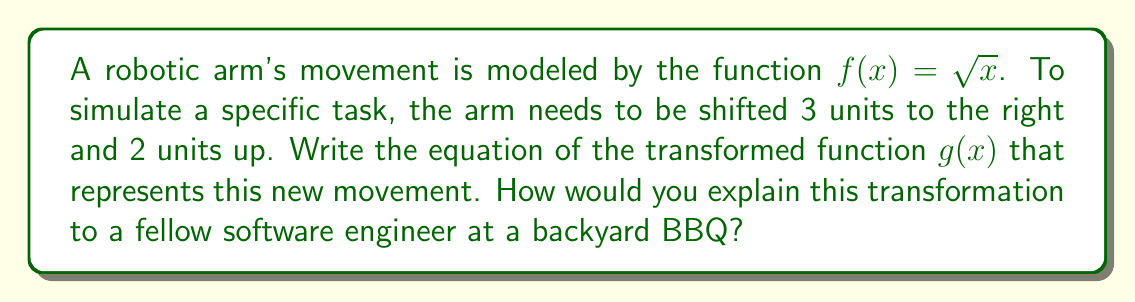What is the answer to this math problem? To explain this to a fellow software engineer at a backyard BBQ, we can break it down into steps that relate to software concepts:

1. Original function (baseline code):
   $f(x) = \sqrt{x}$

2. Horizontal shift (input preprocessing):
   To shift 3 units right, we replace $x$ with $(x - 3)$. This is like preprocessing the input before it goes into the main function.
   $f(x - 3) = \sqrt{x - 3}$

3. Vertical shift (output post-processing):
   To shift 2 units up, we add 2 to the entire function. This is like post-processing the output after the main function has run.
   $g(x) = f(x - 3) + 2 = \sqrt{x - 3} + 2$

4. Final transformed function (modified code):
   $g(x) = \sqrt{x - 3} + 2$

In software terms, this is analogous to:
- Modifying the input parameters (x - 3)
- Applying the core function (square root)
- Post-processing the result (+ 2)

This transformation simulates the robotic arm's new position and movement range, much like how we might adjust the parameters of a function in software to change its behavior.
Answer: $g(x) = \sqrt{x - 3} + 2$ 